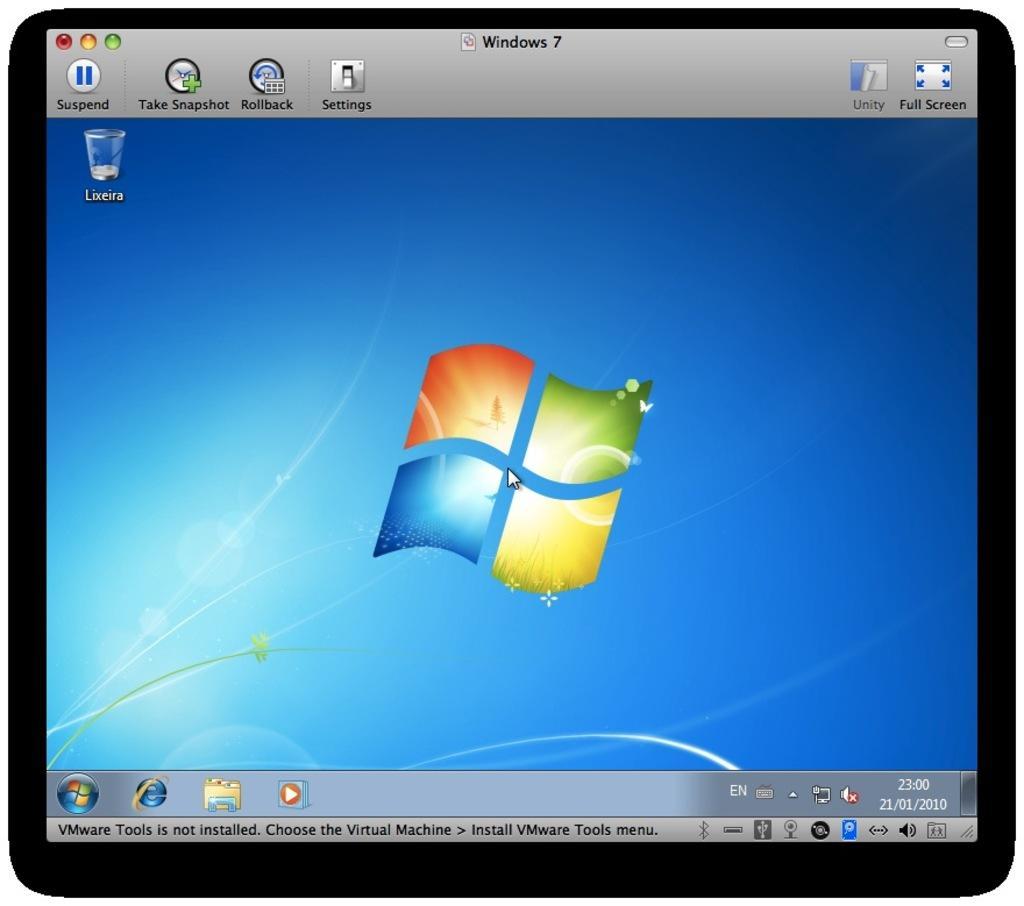In one or two sentences, can you explain what this image depicts? In this picture we can see a monitor screen, here we can see some symbols, some text and some numbers on it. 